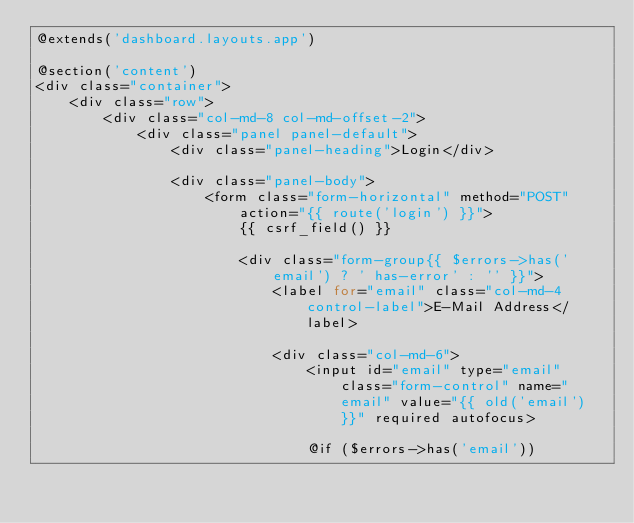<code> <loc_0><loc_0><loc_500><loc_500><_PHP_>@extends('dashboard.layouts.app')

@section('content')
<div class="container">
    <div class="row">
        <div class="col-md-8 col-md-offset-2">
            <div class="panel panel-default">
                <div class="panel-heading">Login</div>

                <div class="panel-body">
                    <form class="form-horizontal" method="POST" action="{{ route('login') }}">
                        {{ csrf_field() }}

                        <div class="form-group{{ $errors->has('email') ? ' has-error' : '' }}">
                            <label for="email" class="col-md-4 control-label">E-Mail Address</label>

                            <div class="col-md-6">
                                <input id="email" type="email" class="form-control" name="email" value="{{ old('email') }}" required autofocus>

                                @if ($errors->has('email'))</code> 